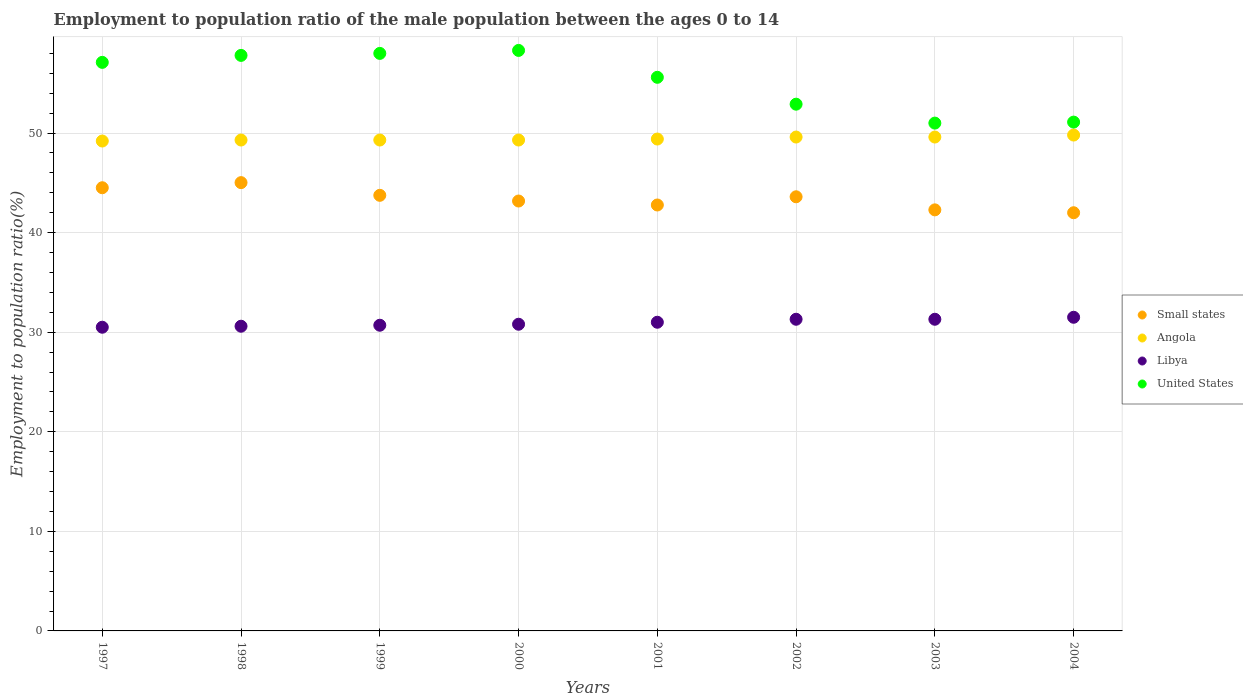How many different coloured dotlines are there?
Offer a terse response. 4. Is the number of dotlines equal to the number of legend labels?
Make the answer very short. Yes. What is the employment to population ratio in Small states in 2002?
Offer a very short reply. 43.6. Across all years, what is the maximum employment to population ratio in Libya?
Make the answer very short. 31.5. Across all years, what is the minimum employment to population ratio in Small states?
Provide a succinct answer. 42. In which year was the employment to population ratio in United States minimum?
Ensure brevity in your answer.  2003. What is the total employment to population ratio in Angola in the graph?
Keep it short and to the point. 395.5. What is the difference between the employment to population ratio in Libya in 1997 and that in 2003?
Offer a terse response. -0.8. What is the difference between the employment to population ratio in United States in 1997 and the employment to population ratio in Libya in 2000?
Make the answer very short. 26.3. What is the average employment to population ratio in Angola per year?
Offer a very short reply. 49.44. In the year 1998, what is the difference between the employment to population ratio in Angola and employment to population ratio in Small states?
Your answer should be compact. 4.28. What is the ratio of the employment to population ratio in Libya in 1997 to that in 2001?
Make the answer very short. 0.98. Is the difference between the employment to population ratio in Angola in 1999 and 2004 greater than the difference between the employment to population ratio in Small states in 1999 and 2004?
Ensure brevity in your answer.  No. What is the difference between the highest and the second highest employment to population ratio in United States?
Keep it short and to the point. 0.3. What is the difference between the highest and the lowest employment to population ratio in Libya?
Ensure brevity in your answer.  1. Is the sum of the employment to population ratio in Small states in 1997 and 2002 greater than the maximum employment to population ratio in Libya across all years?
Keep it short and to the point. Yes. Is it the case that in every year, the sum of the employment to population ratio in United States and employment to population ratio in Angola  is greater than the sum of employment to population ratio in Libya and employment to population ratio in Small states?
Make the answer very short. Yes. Is the employment to population ratio in Libya strictly less than the employment to population ratio in Small states over the years?
Your answer should be very brief. Yes. How many dotlines are there?
Provide a short and direct response. 4. Does the graph contain any zero values?
Provide a short and direct response. No. Where does the legend appear in the graph?
Provide a short and direct response. Center right. How many legend labels are there?
Your answer should be compact. 4. What is the title of the graph?
Your answer should be very brief. Employment to population ratio of the male population between the ages 0 to 14. What is the Employment to population ratio(%) in Small states in 1997?
Your response must be concise. 44.51. What is the Employment to population ratio(%) in Angola in 1997?
Your answer should be very brief. 49.2. What is the Employment to population ratio(%) in Libya in 1997?
Provide a succinct answer. 30.5. What is the Employment to population ratio(%) of United States in 1997?
Your answer should be compact. 57.1. What is the Employment to population ratio(%) of Small states in 1998?
Offer a terse response. 45.02. What is the Employment to population ratio(%) in Angola in 1998?
Keep it short and to the point. 49.3. What is the Employment to population ratio(%) of Libya in 1998?
Offer a very short reply. 30.6. What is the Employment to population ratio(%) of United States in 1998?
Offer a very short reply. 57.8. What is the Employment to population ratio(%) of Small states in 1999?
Provide a succinct answer. 43.75. What is the Employment to population ratio(%) of Angola in 1999?
Keep it short and to the point. 49.3. What is the Employment to population ratio(%) in Libya in 1999?
Provide a succinct answer. 30.7. What is the Employment to population ratio(%) of Small states in 2000?
Keep it short and to the point. 43.17. What is the Employment to population ratio(%) of Angola in 2000?
Provide a succinct answer. 49.3. What is the Employment to population ratio(%) of Libya in 2000?
Ensure brevity in your answer.  30.8. What is the Employment to population ratio(%) in United States in 2000?
Keep it short and to the point. 58.3. What is the Employment to population ratio(%) in Small states in 2001?
Offer a terse response. 42.78. What is the Employment to population ratio(%) of Angola in 2001?
Your answer should be very brief. 49.4. What is the Employment to population ratio(%) of United States in 2001?
Keep it short and to the point. 55.6. What is the Employment to population ratio(%) in Small states in 2002?
Your response must be concise. 43.6. What is the Employment to population ratio(%) of Angola in 2002?
Ensure brevity in your answer.  49.6. What is the Employment to population ratio(%) in Libya in 2002?
Your answer should be very brief. 31.3. What is the Employment to population ratio(%) of United States in 2002?
Your response must be concise. 52.9. What is the Employment to population ratio(%) of Small states in 2003?
Give a very brief answer. 42.29. What is the Employment to population ratio(%) of Angola in 2003?
Keep it short and to the point. 49.6. What is the Employment to population ratio(%) of Libya in 2003?
Offer a terse response. 31.3. What is the Employment to population ratio(%) of United States in 2003?
Keep it short and to the point. 51. What is the Employment to population ratio(%) of Small states in 2004?
Keep it short and to the point. 42. What is the Employment to population ratio(%) of Angola in 2004?
Your answer should be compact. 49.8. What is the Employment to population ratio(%) in Libya in 2004?
Give a very brief answer. 31.5. What is the Employment to population ratio(%) of United States in 2004?
Provide a succinct answer. 51.1. Across all years, what is the maximum Employment to population ratio(%) of Small states?
Ensure brevity in your answer.  45.02. Across all years, what is the maximum Employment to population ratio(%) in Angola?
Provide a short and direct response. 49.8. Across all years, what is the maximum Employment to population ratio(%) in Libya?
Your answer should be very brief. 31.5. Across all years, what is the maximum Employment to population ratio(%) in United States?
Provide a succinct answer. 58.3. Across all years, what is the minimum Employment to population ratio(%) of Small states?
Your response must be concise. 42. Across all years, what is the minimum Employment to population ratio(%) in Angola?
Provide a short and direct response. 49.2. Across all years, what is the minimum Employment to population ratio(%) in Libya?
Your answer should be very brief. 30.5. What is the total Employment to population ratio(%) in Small states in the graph?
Keep it short and to the point. 347.11. What is the total Employment to population ratio(%) in Angola in the graph?
Keep it short and to the point. 395.5. What is the total Employment to population ratio(%) of Libya in the graph?
Your answer should be very brief. 247.7. What is the total Employment to population ratio(%) in United States in the graph?
Provide a succinct answer. 441.8. What is the difference between the Employment to population ratio(%) in Small states in 1997 and that in 1998?
Offer a terse response. -0.51. What is the difference between the Employment to population ratio(%) in Angola in 1997 and that in 1998?
Your answer should be very brief. -0.1. What is the difference between the Employment to population ratio(%) of Libya in 1997 and that in 1998?
Ensure brevity in your answer.  -0.1. What is the difference between the Employment to population ratio(%) of United States in 1997 and that in 1998?
Provide a short and direct response. -0.7. What is the difference between the Employment to population ratio(%) of Small states in 1997 and that in 1999?
Provide a succinct answer. 0.76. What is the difference between the Employment to population ratio(%) of United States in 1997 and that in 1999?
Provide a succinct answer. -0.9. What is the difference between the Employment to population ratio(%) of Small states in 1997 and that in 2000?
Ensure brevity in your answer.  1.33. What is the difference between the Employment to population ratio(%) of Angola in 1997 and that in 2000?
Make the answer very short. -0.1. What is the difference between the Employment to population ratio(%) in Small states in 1997 and that in 2001?
Ensure brevity in your answer.  1.73. What is the difference between the Employment to population ratio(%) of Libya in 1997 and that in 2001?
Offer a very short reply. -0.5. What is the difference between the Employment to population ratio(%) of United States in 1997 and that in 2001?
Make the answer very short. 1.5. What is the difference between the Employment to population ratio(%) in Small states in 1997 and that in 2002?
Provide a succinct answer. 0.91. What is the difference between the Employment to population ratio(%) of United States in 1997 and that in 2002?
Your answer should be very brief. 4.2. What is the difference between the Employment to population ratio(%) of Small states in 1997 and that in 2003?
Ensure brevity in your answer.  2.22. What is the difference between the Employment to population ratio(%) of Angola in 1997 and that in 2003?
Make the answer very short. -0.4. What is the difference between the Employment to population ratio(%) of Libya in 1997 and that in 2003?
Ensure brevity in your answer.  -0.8. What is the difference between the Employment to population ratio(%) in United States in 1997 and that in 2003?
Your answer should be very brief. 6.1. What is the difference between the Employment to population ratio(%) in Small states in 1997 and that in 2004?
Provide a succinct answer. 2.51. What is the difference between the Employment to population ratio(%) of Libya in 1997 and that in 2004?
Provide a short and direct response. -1. What is the difference between the Employment to population ratio(%) of Small states in 1998 and that in 1999?
Keep it short and to the point. 1.27. What is the difference between the Employment to population ratio(%) of Angola in 1998 and that in 1999?
Make the answer very short. 0. What is the difference between the Employment to population ratio(%) in United States in 1998 and that in 1999?
Your answer should be compact. -0.2. What is the difference between the Employment to population ratio(%) in Small states in 1998 and that in 2000?
Ensure brevity in your answer.  1.85. What is the difference between the Employment to population ratio(%) in Angola in 1998 and that in 2000?
Give a very brief answer. 0. What is the difference between the Employment to population ratio(%) in United States in 1998 and that in 2000?
Give a very brief answer. -0.5. What is the difference between the Employment to population ratio(%) of Small states in 1998 and that in 2001?
Give a very brief answer. 2.25. What is the difference between the Employment to population ratio(%) in United States in 1998 and that in 2001?
Offer a terse response. 2.2. What is the difference between the Employment to population ratio(%) of Small states in 1998 and that in 2002?
Give a very brief answer. 1.42. What is the difference between the Employment to population ratio(%) of Angola in 1998 and that in 2002?
Your answer should be very brief. -0.3. What is the difference between the Employment to population ratio(%) in United States in 1998 and that in 2002?
Offer a very short reply. 4.9. What is the difference between the Employment to population ratio(%) in Small states in 1998 and that in 2003?
Offer a terse response. 2.73. What is the difference between the Employment to population ratio(%) of Libya in 1998 and that in 2003?
Your answer should be compact. -0.7. What is the difference between the Employment to population ratio(%) in United States in 1998 and that in 2003?
Your answer should be very brief. 6.8. What is the difference between the Employment to population ratio(%) of Small states in 1998 and that in 2004?
Your answer should be very brief. 3.02. What is the difference between the Employment to population ratio(%) of Libya in 1998 and that in 2004?
Your response must be concise. -0.9. What is the difference between the Employment to population ratio(%) of Small states in 1999 and that in 2000?
Your answer should be compact. 0.57. What is the difference between the Employment to population ratio(%) in Angola in 1999 and that in 2000?
Your answer should be very brief. 0. What is the difference between the Employment to population ratio(%) in United States in 1999 and that in 2000?
Ensure brevity in your answer.  -0.3. What is the difference between the Employment to population ratio(%) in Small states in 1999 and that in 2001?
Your response must be concise. 0.97. What is the difference between the Employment to population ratio(%) in Angola in 1999 and that in 2001?
Give a very brief answer. -0.1. What is the difference between the Employment to population ratio(%) of Small states in 1999 and that in 2002?
Provide a short and direct response. 0.15. What is the difference between the Employment to population ratio(%) of Angola in 1999 and that in 2002?
Offer a very short reply. -0.3. What is the difference between the Employment to population ratio(%) of Libya in 1999 and that in 2002?
Ensure brevity in your answer.  -0.6. What is the difference between the Employment to population ratio(%) in United States in 1999 and that in 2002?
Ensure brevity in your answer.  5.1. What is the difference between the Employment to population ratio(%) in Small states in 1999 and that in 2003?
Make the answer very short. 1.46. What is the difference between the Employment to population ratio(%) of Libya in 1999 and that in 2003?
Give a very brief answer. -0.6. What is the difference between the Employment to population ratio(%) of Small states in 1999 and that in 2004?
Make the answer very short. 1.75. What is the difference between the Employment to population ratio(%) in Angola in 1999 and that in 2004?
Provide a short and direct response. -0.5. What is the difference between the Employment to population ratio(%) of Libya in 1999 and that in 2004?
Offer a terse response. -0.8. What is the difference between the Employment to population ratio(%) in United States in 1999 and that in 2004?
Your response must be concise. 6.9. What is the difference between the Employment to population ratio(%) in Small states in 2000 and that in 2001?
Keep it short and to the point. 0.4. What is the difference between the Employment to population ratio(%) in Angola in 2000 and that in 2001?
Give a very brief answer. -0.1. What is the difference between the Employment to population ratio(%) in Libya in 2000 and that in 2001?
Your answer should be compact. -0.2. What is the difference between the Employment to population ratio(%) of Small states in 2000 and that in 2002?
Ensure brevity in your answer.  -0.43. What is the difference between the Employment to population ratio(%) in Angola in 2000 and that in 2002?
Offer a very short reply. -0.3. What is the difference between the Employment to population ratio(%) of Libya in 2000 and that in 2002?
Offer a terse response. -0.5. What is the difference between the Employment to population ratio(%) of Small states in 2000 and that in 2003?
Provide a short and direct response. 0.89. What is the difference between the Employment to population ratio(%) in Libya in 2000 and that in 2003?
Offer a very short reply. -0.5. What is the difference between the Employment to population ratio(%) in United States in 2000 and that in 2003?
Offer a terse response. 7.3. What is the difference between the Employment to population ratio(%) in Small states in 2000 and that in 2004?
Give a very brief answer. 1.18. What is the difference between the Employment to population ratio(%) of United States in 2000 and that in 2004?
Provide a succinct answer. 7.2. What is the difference between the Employment to population ratio(%) of Small states in 2001 and that in 2002?
Provide a succinct answer. -0.82. What is the difference between the Employment to population ratio(%) of Angola in 2001 and that in 2002?
Ensure brevity in your answer.  -0.2. What is the difference between the Employment to population ratio(%) of Libya in 2001 and that in 2002?
Provide a succinct answer. -0.3. What is the difference between the Employment to population ratio(%) in Small states in 2001 and that in 2003?
Your response must be concise. 0.49. What is the difference between the Employment to population ratio(%) of Angola in 2001 and that in 2003?
Make the answer very short. -0.2. What is the difference between the Employment to population ratio(%) of United States in 2001 and that in 2003?
Your answer should be very brief. 4.6. What is the difference between the Employment to population ratio(%) in Small states in 2001 and that in 2004?
Your response must be concise. 0.78. What is the difference between the Employment to population ratio(%) of Angola in 2001 and that in 2004?
Provide a short and direct response. -0.4. What is the difference between the Employment to population ratio(%) in Libya in 2001 and that in 2004?
Give a very brief answer. -0.5. What is the difference between the Employment to population ratio(%) of Small states in 2002 and that in 2003?
Make the answer very short. 1.31. What is the difference between the Employment to population ratio(%) in Libya in 2002 and that in 2003?
Your response must be concise. 0. What is the difference between the Employment to population ratio(%) of Small states in 2002 and that in 2004?
Your answer should be very brief. 1.6. What is the difference between the Employment to population ratio(%) of United States in 2002 and that in 2004?
Give a very brief answer. 1.8. What is the difference between the Employment to population ratio(%) of Small states in 2003 and that in 2004?
Offer a very short reply. 0.29. What is the difference between the Employment to population ratio(%) in United States in 2003 and that in 2004?
Provide a short and direct response. -0.1. What is the difference between the Employment to population ratio(%) in Small states in 1997 and the Employment to population ratio(%) in Angola in 1998?
Give a very brief answer. -4.79. What is the difference between the Employment to population ratio(%) in Small states in 1997 and the Employment to population ratio(%) in Libya in 1998?
Give a very brief answer. 13.91. What is the difference between the Employment to population ratio(%) of Small states in 1997 and the Employment to population ratio(%) of United States in 1998?
Give a very brief answer. -13.29. What is the difference between the Employment to population ratio(%) in Libya in 1997 and the Employment to population ratio(%) in United States in 1998?
Your answer should be very brief. -27.3. What is the difference between the Employment to population ratio(%) in Small states in 1997 and the Employment to population ratio(%) in Angola in 1999?
Offer a very short reply. -4.79. What is the difference between the Employment to population ratio(%) in Small states in 1997 and the Employment to population ratio(%) in Libya in 1999?
Provide a short and direct response. 13.81. What is the difference between the Employment to population ratio(%) in Small states in 1997 and the Employment to population ratio(%) in United States in 1999?
Make the answer very short. -13.49. What is the difference between the Employment to population ratio(%) of Angola in 1997 and the Employment to population ratio(%) of Libya in 1999?
Provide a succinct answer. 18.5. What is the difference between the Employment to population ratio(%) in Angola in 1997 and the Employment to population ratio(%) in United States in 1999?
Your answer should be very brief. -8.8. What is the difference between the Employment to population ratio(%) in Libya in 1997 and the Employment to population ratio(%) in United States in 1999?
Ensure brevity in your answer.  -27.5. What is the difference between the Employment to population ratio(%) in Small states in 1997 and the Employment to population ratio(%) in Angola in 2000?
Give a very brief answer. -4.79. What is the difference between the Employment to population ratio(%) of Small states in 1997 and the Employment to population ratio(%) of Libya in 2000?
Keep it short and to the point. 13.71. What is the difference between the Employment to population ratio(%) of Small states in 1997 and the Employment to population ratio(%) of United States in 2000?
Your answer should be very brief. -13.79. What is the difference between the Employment to population ratio(%) in Libya in 1997 and the Employment to population ratio(%) in United States in 2000?
Offer a terse response. -27.8. What is the difference between the Employment to population ratio(%) in Small states in 1997 and the Employment to population ratio(%) in Angola in 2001?
Your answer should be very brief. -4.89. What is the difference between the Employment to population ratio(%) of Small states in 1997 and the Employment to population ratio(%) of Libya in 2001?
Give a very brief answer. 13.51. What is the difference between the Employment to population ratio(%) of Small states in 1997 and the Employment to population ratio(%) of United States in 2001?
Provide a short and direct response. -11.09. What is the difference between the Employment to population ratio(%) in Angola in 1997 and the Employment to population ratio(%) in Libya in 2001?
Make the answer very short. 18.2. What is the difference between the Employment to population ratio(%) in Libya in 1997 and the Employment to population ratio(%) in United States in 2001?
Ensure brevity in your answer.  -25.1. What is the difference between the Employment to population ratio(%) in Small states in 1997 and the Employment to population ratio(%) in Angola in 2002?
Provide a short and direct response. -5.09. What is the difference between the Employment to population ratio(%) in Small states in 1997 and the Employment to population ratio(%) in Libya in 2002?
Ensure brevity in your answer.  13.21. What is the difference between the Employment to population ratio(%) of Small states in 1997 and the Employment to population ratio(%) of United States in 2002?
Ensure brevity in your answer.  -8.39. What is the difference between the Employment to population ratio(%) in Libya in 1997 and the Employment to population ratio(%) in United States in 2002?
Offer a terse response. -22.4. What is the difference between the Employment to population ratio(%) in Small states in 1997 and the Employment to population ratio(%) in Angola in 2003?
Make the answer very short. -5.09. What is the difference between the Employment to population ratio(%) in Small states in 1997 and the Employment to population ratio(%) in Libya in 2003?
Offer a very short reply. 13.21. What is the difference between the Employment to population ratio(%) in Small states in 1997 and the Employment to population ratio(%) in United States in 2003?
Keep it short and to the point. -6.49. What is the difference between the Employment to population ratio(%) in Libya in 1997 and the Employment to population ratio(%) in United States in 2003?
Provide a short and direct response. -20.5. What is the difference between the Employment to population ratio(%) of Small states in 1997 and the Employment to population ratio(%) of Angola in 2004?
Ensure brevity in your answer.  -5.29. What is the difference between the Employment to population ratio(%) of Small states in 1997 and the Employment to population ratio(%) of Libya in 2004?
Ensure brevity in your answer.  13.01. What is the difference between the Employment to population ratio(%) in Small states in 1997 and the Employment to population ratio(%) in United States in 2004?
Offer a terse response. -6.59. What is the difference between the Employment to population ratio(%) of Angola in 1997 and the Employment to population ratio(%) of United States in 2004?
Your response must be concise. -1.9. What is the difference between the Employment to population ratio(%) in Libya in 1997 and the Employment to population ratio(%) in United States in 2004?
Give a very brief answer. -20.6. What is the difference between the Employment to population ratio(%) in Small states in 1998 and the Employment to population ratio(%) in Angola in 1999?
Provide a succinct answer. -4.28. What is the difference between the Employment to population ratio(%) in Small states in 1998 and the Employment to population ratio(%) in Libya in 1999?
Your response must be concise. 14.32. What is the difference between the Employment to population ratio(%) of Small states in 1998 and the Employment to population ratio(%) of United States in 1999?
Give a very brief answer. -12.98. What is the difference between the Employment to population ratio(%) of Libya in 1998 and the Employment to population ratio(%) of United States in 1999?
Offer a terse response. -27.4. What is the difference between the Employment to population ratio(%) in Small states in 1998 and the Employment to population ratio(%) in Angola in 2000?
Make the answer very short. -4.28. What is the difference between the Employment to population ratio(%) in Small states in 1998 and the Employment to population ratio(%) in Libya in 2000?
Keep it short and to the point. 14.22. What is the difference between the Employment to population ratio(%) of Small states in 1998 and the Employment to population ratio(%) of United States in 2000?
Make the answer very short. -13.28. What is the difference between the Employment to population ratio(%) in Angola in 1998 and the Employment to population ratio(%) in United States in 2000?
Your response must be concise. -9. What is the difference between the Employment to population ratio(%) of Libya in 1998 and the Employment to population ratio(%) of United States in 2000?
Ensure brevity in your answer.  -27.7. What is the difference between the Employment to population ratio(%) in Small states in 1998 and the Employment to population ratio(%) in Angola in 2001?
Provide a succinct answer. -4.38. What is the difference between the Employment to population ratio(%) of Small states in 1998 and the Employment to population ratio(%) of Libya in 2001?
Keep it short and to the point. 14.02. What is the difference between the Employment to population ratio(%) of Small states in 1998 and the Employment to population ratio(%) of United States in 2001?
Your response must be concise. -10.58. What is the difference between the Employment to population ratio(%) in Angola in 1998 and the Employment to population ratio(%) in United States in 2001?
Give a very brief answer. -6.3. What is the difference between the Employment to population ratio(%) of Libya in 1998 and the Employment to population ratio(%) of United States in 2001?
Make the answer very short. -25. What is the difference between the Employment to population ratio(%) of Small states in 1998 and the Employment to population ratio(%) of Angola in 2002?
Give a very brief answer. -4.58. What is the difference between the Employment to population ratio(%) in Small states in 1998 and the Employment to population ratio(%) in Libya in 2002?
Offer a very short reply. 13.72. What is the difference between the Employment to population ratio(%) of Small states in 1998 and the Employment to population ratio(%) of United States in 2002?
Keep it short and to the point. -7.88. What is the difference between the Employment to population ratio(%) in Angola in 1998 and the Employment to population ratio(%) in Libya in 2002?
Offer a terse response. 18. What is the difference between the Employment to population ratio(%) of Angola in 1998 and the Employment to population ratio(%) of United States in 2002?
Give a very brief answer. -3.6. What is the difference between the Employment to population ratio(%) in Libya in 1998 and the Employment to population ratio(%) in United States in 2002?
Keep it short and to the point. -22.3. What is the difference between the Employment to population ratio(%) of Small states in 1998 and the Employment to population ratio(%) of Angola in 2003?
Give a very brief answer. -4.58. What is the difference between the Employment to population ratio(%) in Small states in 1998 and the Employment to population ratio(%) in Libya in 2003?
Ensure brevity in your answer.  13.72. What is the difference between the Employment to population ratio(%) of Small states in 1998 and the Employment to population ratio(%) of United States in 2003?
Offer a terse response. -5.98. What is the difference between the Employment to population ratio(%) in Angola in 1998 and the Employment to population ratio(%) in Libya in 2003?
Your answer should be compact. 18. What is the difference between the Employment to population ratio(%) of Angola in 1998 and the Employment to population ratio(%) of United States in 2003?
Provide a succinct answer. -1.7. What is the difference between the Employment to population ratio(%) of Libya in 1998 and the Employment to population ratio(%) of United States in 2003?
Offer a very short reply. -20.4. What is the difference between the Employment to population ratio(%) of Small states in 1998 and the Employment to population ratio(%) of Angola in 2004?
Offer a terse response. -4.78. What is the difference between the Employment to population ratio(%) of Small states in 1998 and the Employment to population ratio(%) of Libya in 2004?
Make the answer very short. 13.52. What is the difference between the Employment to population ratio(%) in Small states in 1998 and the Employment to population ratio(%) in United States in 2004?
Ensure brevity in your answer.  -6.08. What is the difference between the Employment to population ratio(%) of Angola in 1998 and the Employment to population ratio(%) of United States in 2004?
Provide a succinct answer. -1.8. What is the difference between the Employment to population ratio(%) in Libya in 1998 and the Employment to population ratio(%) in United States in 2004?
Ensure brevity in your answer.  -20.5. What is the difference between the Employment to population ratio(%) in Small states in 1999 and the Employment to population ratio(%) in Angola in 2000?
Your response must be concise. -5.55. What is the difference between the Employment to population ratio(%) in Small states in 1999 and the Employment to population ratio(%) in Libya in 2000?
Give a very brief answer. 12.95. What is the difference between the Employment to population ratio(%) of Small states in 1999 and the Employment to population ratio(%) of United States in 2000?
Give a very brief answer. -14.55. What is the difference between the Employment to population ratio(%) in Angola in 1999 and the Employment to population ratio(%) in United States in 2000?
Your answer should be very brief. -9. What is the difference between the Employment to population ratio(%) of Libya in 1999 and the Employment to population ratio(%) of United States in 2000?
Your answer should be compact. -27.6. What is the difference between the Employment to population ratio(%) in Small states in 1999 and the Employment to population ratio(%) in Angola in 2001?
Offer a terse response. -5.65. What is the difference between the Employment to population ratio(%) in Small states in 1999 and the Employment to population ratio(%) in Libya in 2001?
Provide a succinct answer. 12.75. What is the difference between the Employment to population ratio(%) in Small states in 1999 and the Employment to population ratio(%) in United States in 2001?
Your answer should be very brief. -11.85. What is the difference between the Employment to population ratio(%) of Angola in 1999 and the Employment to population ratio(%) of United States in 2001?
Your answer should be very brief. -6.3. What is the difference between the Employment to population ratio(%) in Libya in 1999 and the Employment to population ratio(%) in United States in 2001?
Your answer should be compact. -24.9. What is the difference between the Employment to population ratio(%) of Small states in 1999 and the Employment to population ratio(%) of Angola in 2002?
Give a very brief answer. -5.85. What is the difference between the Employment to population ratio(%) of Small states in 1999 and the Employment to population ratio(%) of Libya in 2002?
Make the answer very short. 12.45. What is the difference between the Employment to population ratio(%) of Small states in 1999 and the Employment to population ratio(%) of United States in 2002?
Your response must be concise. -9.15. What is the difference between the Employment to population ratio(%) of Angola in 1999 and the Employment to population ratio(%) of United States in 2002?
Ensure brevity in your answer.  -3.6. What is the difference between the Employment to population ratio(%) in Libya in 1999 and the Employment to population ratio(%) in United States in 2002?
Offer a very short reply. -22.2. What is the difference between the Employment to population ratio(%) in Small states in 1999 and the Employment to population ratio(%) in Angola in 2003?
Your response must be concise. -5.85. What is the difference between the Employment to population ratio(%) of Small states in 1999 and the Employment to population ratio(%) of Libya in 2003?
Provide a succinct answer. 12.45. What is the difference between the Employment to population ratio(%) in Small states in 1999 and the Employment to population ratio(%) in United States in 2003?
Your answer should be very brief. -7.25. What is the difference between the Employment to population ratio(%) of Angola in 1999 and the Employment to population ratio(%) of United States in 2003?
Offer a terse response. -1.7. What is the difference between the Employment to population ratio(%) in Libya in 1999 and the Employment to population ratio(%) in United States in 2003?
Provide a succinct answer. -20.3. What is the difference between the Employment to population ratio(%) in Small states in 1999 and the Employment to population ratio(%) in Angola in 2004?
Keep it short and to the point. -6.05. What is the difference between the Employment to population ratio(%) in Small states in 1999 and the Employment to population ratio(%) in Libya in 2004?
Your answer should be very brief. 12.25. What is the difference between the Employment to population ratio(%) in Small states in 1999 and the Employment to population ratio(%) in United States in 2004?
Your response must be concise. -7.35. What is the difference between the Employment to population ratio(%) in Angola in 1999 and the Employment to population ratio(%) in Libya in 2004?
Keep it short and to the point. 17.8. What is the difference between the Employment to population ratio(%) of Libya in 1999 and the Employment to population ratio(%) of United States in 2004?
Ensure brevity in your answer.  -20.4. What is the difference between the Employment to population ratio(%) in Small states in 2000 and the Employment to population ratio(%) in Angola in 2001?
Your response must be concise. -6.23. What is the difference between the Employment to population ratio(%) in Small states in 2000 and the Employment to population ratio(%) in Libya in 2001?
Your answer should be very brief. 12.17. What is the difference between the Employment to population ratio(%) in Small states in 2000 and the Employment to population ratio(%) in United States in 2001?
Provide a short and direct response. -12.43. What is the difference between the Employment to population ratio(%) of Angola in 2000 and the Employment to population ratio(%) of United States in 2001?
Your response must be concise. -6.3. What is the difference between the Employment to population ratio(%) in Libya in 2000 and the Employment to population ratio(%) in United States in 2001?
Provide a succinct answer. -24.8. What is the difference between the Employment to population ratio(%) in Small states in 2000 and the Employment to population ratio(%) in Angola in 2002?
Your answer should be compact. -6.43. What is the difference between the Employment to population ratio(%) of Small states in 2000 and the Employment to population ratio(%) of Libya in 2002?
Your response must be concise. 11.87. What is the difference between the Employment to population ratio(%) in Small states in 2000 and the Employment to population ratio(%) in United States in 2002?
Your answer should be compact. -9.73. What is the difference between the Employment to population ratio(%) in Angola in 2000 and the Employment to population ratio(%) in Libya in 2002?
Offer a very short reply. 18. What is the difference between the Employment to population ratio(%) of Angola in 2000 and the Employment to population ratio(%) of United States in 2002?
Offer a very short reply. -3.6. What is the difference between the Employment to population ratio(%) of Libya in 2000 and the Employment to population ratio(%) of United States in 2002?
Your answer should be very brief. -22.1. What is the difference between the Employment to population ratio(%) of Small states in 2000 and the Employment to population ratio(%) of Angola in 2003?
Provide a short and direct response. -6.43. What is the difference between the Employment to population ratio(%) in Small states in 2000 and the Employment to population ratio(%) in Libya in 2003?
Provide a short and direct response. 11.87. What is the difference between the Employment to population ratio(%) of Small states in 2000 and the Employment to population ratio(%) of United States in 2003?
Your response must be concise. -7.83. What is the difference between the Employment to population ratio(%) in Angola in 2000 and the Employment to population ratio(%) in United States in 2003?
Provide a succinct answer. -1.7. What is the difference between the Employment to population ratio(%) in Libya in 2000 and the Employment to population ratio(%) in United States in 2003?
Offer a terse response. -20.2. What is the difference between the Employment to population ratio(%) in Small states in 2000 and the Employment to population ratio(%) in Angola in 2004?
Your response must be concise. -6.63. What is the difference between the Employment to population ratio(%) in Small states in 2000 and the Employment to population ratio(%) in Libya in 2004?
Provide a short and direct response. 11.67. What is the difference between the Employment to population ratio(%) in Small states in 2000 and the Employment to population ratio(%) in United States in 2004?
Ensure brevity in your answer.  -7.93. What is the difference between the Employment to population ratio(%) of Libya in 2000 and the Employment to population ratio(%) of United States in 2004?
Give a very brief answer. -20.3. What is the difference between the Employment to population ratio(%) of Small states in 2001 and the Employment to population ratio(%) of Angola in 2002?
Provide a succinct answer. -6.82. What is the difference between the Employment to population ratio(%) of Small states in 2001 and the Employment to population ratio(%) of Libya in 2002?
Your answer should be compact. 11.48. What is the difference between the Employment to population ratio(%) in Small states in 2001 and the Employment to population ratio(%) in United States in 2002?
Your answer should be very brief. -10.12. What is the difference between the Employment to population ratio(%) of Angola in 2001 and the Employment to population ratio(%) of Libya in 2002?
Your response must be concise. 18.1. What is the difference between the Employment to population ratio(%) in Angola in 2001 and the Employment to population ratio(%) in United States in 2002?
Offer a very short reply. -3.5. What is the difference between the Employment to population ratio(%) in Libya in 2001 and the Employment to population ratio(%) in United States in 2002?
Ensure brevity in your answer.  -21.9. What is the difference between the Employment to population ratio(%) in Small states in 2001 and the Employment to population ratio(%) in Angola in 2003?
Offer a terse response. -6.82. What is the difference between the Employment to population ratio(%) of Small states in 2001 and the Employment to population ratio(%) of Libya in 2003?
Your response must be concise. 11.48. What is the difference between the Employment to population ratio(%) in Small states in 2001 and the Employment to population ratio(%) in United States in 2003?
Offer a very short reply. -8.22. What is the difference between the Employment to population ratio(%) of Small states in 2001 and the Employment to population ratio(%) of Angola in 2004?
Make the answer very short. -7.02. What is the difference between the Employment to population ratio(%) of Small states in 2001 and the Employment to population ratio(%) of Libya in 2004?
Provide a short and direct response. 11.28. What is the difference between the Employment to population ratio(%) of Small states in 2001 and the Employment to population ratio(%) of United States in 2004?
Offer a very short reply. -8.32. What is the difference between the Employment to population ratio(%) of Angola in 2001 and the Employment to population ratio(%) of Libya in 2004?
Give a very brief answer. 17.9. What is the difference between the Employment to population ratio(%) in Libya in 2001 and the Employment to population ratio(%) in United States in 2004?
Give a very brief answer. -20.1. What is the difference between the Employment to population ratio(%) of Small states in 2002 and the Employment to population ratio(%) of Angola in 2003?
Provide a short and direct response. -6. What is the difference between the Employment to population ratio(%) of Small states in 2002 and the Employment to population ratio(%) of Libya in 2003?
Ensure brevity in your answer.  12.3. What is the difference between the Employment to population ratio(%) of Small states in 2002 and the Employment to population ratio(%) of United States in 2003?
Your answer should be compact. -7.4. What is the difference between the Employment to population ratio(%) of Angola in 2002 and the Employment to population ratio(%) of Libya in 2003?
Your answer should be compact. 18.3. What is the difference between the Employment to population ratio(%) in Libya in 2002 and the Employment to population ratio(%) in United States in 2003?
Offer a terse response. -19.7. What is the difference between the Employment to population ratio(%) of Small states in 2002 and the Employment to population ratio(%) of Angola in 2004?
Your answer should be very brief. -6.2. What is the difference between the Employment to population ratio(%) in Small states in 2002 and the Employment to population ratio(%) in Libya in 2004?
Offer a terse response. 12.1. What is the difference between the Employment to population ratio(%) in Small states in 2002 and the Employment to population ratio(%) in United States in 2004?
Give a very brief answer. -7.5. What is the difference between the Employment to population ratio(%) in Angola in 2002 and the Employment to population ratio(%) in Libya in 2004?
Keep it short and to the point. 18.1. What is the difference between the Employment to population ratio(%) of Angola in 2002 and the Employment to population ratio(%) of United States in 2004?
Your answer should be very brief. -1.5. What is the difference between the Employment to population ratio(%) in Libya in 2002 and the Employment to population ratio(%) in United States in 2004?
Offer a very short reply. -19.8. What is the difference between the Employment to population ratio(%) of Small states in 2003 and the Employment to population ratio(%) of Angola in 2004?
Give a very brief answer. -7.51. What is the difference between the Employment to population ratio(%) in Small states in 2003 and the Employment to population ratio(%) in Libya in 2004?
Offer a terse response. 10.79. What is the difference between the Employment to population ratio(%) of Small states in 2003 and the Employment to population ratio(%) of United States in 2004?
Provide a succinct answer. -8.81. What is the difference between the Employment to population ratio(%) in Angola in 2003 and the Employment to population ratio(%) in Libya in 2004?
Provide a succinct answer. 18.1. What is the difference between the Employment to population ratio(%) of Angola in 2003 and the Employment to population ratio(%) of United States in 2004?
Keep it short and to the point. -1.5. What is the difference between the Employment to population ratio(%) of Libya in 2003 and the Employment to population ratio(%) of United States in 2004?
Your answer should be compact. -19.8. What is the average Employment to population ratio(%) in Small states per year?
Your response must be concise. 43.39. What is the average Employment to population ratio(%) of Angola per year?
Your answer should be very brief. 49.44. What is the average Employment to population ratio(%) of Libya per year?
Your answer should be very brief. 30.96. What is the average Employment to population ratio(%) of United States per year?
Provide a succinct answer. 55.23. In the year 1997, what is the difference between the Employment to population ratio(%) of Small states and Employment to population ratio(%) of Angola?
Keep it short and to the point. -4.69. In the year 1997, what is the difference between the Employment to population ratio(%) in Small states and Employment to population ratio(%) in Libya?
Make the answer very short. 14.01. In the year 1997, what is the difference between the Employment to population ratio(%) in Small states and Employment to population ratio(%) in United States?
Offer a terse response. -12.59. In the year 1997, what is the difference between the Employment to population ratio(%) of Angola and Employment to population ratio(%) of United States?
Make the answer very short. -7.9. In the year 1997, what is the difference between the Employment to population ratio(%) in Libya and Employment to population ratio(%) in United States?
Give a very brief answer. -26.6. In the year 1998, what is the difference between the Employment to population ratio(%) of Small states and Employment to population ratio(%) of Angola?
Make the answer very short. -4.28. In the year 1998, what is the difference between the Employment to population ratio(%) of Small states and Employment to population ratio(%) of Libya?
Ensure brevity in your answer.  14.42. In the year 1998, what is the difference between the Employment to population ratio(%) of Small states and Employment to population ratio(%) of United States?
Offer a terse response. -12.78. In the year 1998, what is the difference between the Employment to population ratio(%) of Libya and Employment to population ratio(%) of United States?
Provide a succinct answer. -27.2. In the year 1999, what is the difference between the Employment to population ratio(%) of Small states and Employment to population ratio(%) of Angola?
Ensure brevity in your answer.  -5.55. In the year 1999, what is the difference between the Employment to population ratio(%) in Small states and Employment to population ratio(%) in Libya?
Provide a short and direct response. 13.05. In the year 1999, what is the difference between the Employment to population ratio(%) of Small states and Employment to population ratio(%) of United States?
Make the answer very short. -14.25. In the year 1999, what is the difference between the Employment to population ratio(%) in Angola and Employment to population ratio(%) in Libya?
Provide a succinct answer. 18.6. In the year 1999, what is the difference between the Employment to population ratio(%) of Angola and Employment to population ratio(%) of United States?
Offer a terse response. -8.7. In the year 1999, what is the difference between the Employment to population ratio(%) of Libya and Employment to population ratio(%) of United States?
Your answer should be very brief. -27.3. In the year 2000, what is the difference between the Employment to population ratio(%) in Small states and Employment to population ratio(%) in Angola?
Your answer should be very brief. -6.13. In the year 2000, what is the difference between the Employment to population ratio(%) in Small states and Employment to population ratio(%) in Libya?
Your response must be concise. 12.37. In the year 2000, what is the difference between the Employment to population ratio(%) in Small states and Employment to population ratio(%) in United States?
Your answer should be very brief. -15.13. In the year 2000, what is the difference between the Employment to population ratio(%) in Angola and Employment to population ratio(%) in Libya?
Keep it short and to the point. 18.5. In the year 2000, what is the difference between the Employment to population ratio(%) of Libya and Employment to population ratio(%) of United States?
Ensure brevity in your answer.  -27.5. In the year 2001, what is the difference between the Employment to population ratio(%) in Small states and Employment to population ratio(%) in Angola?
Your answer should be compact. -6.62. In the year 2001, what is the difference between the Employment to population ratio(%) of Small states and Employment to population ratio(%) of Libya?
Keep it short and to the point. 11.78. In the year 2001, what is the difference between the Employment to population ratio(%) of Small states and Employment to population ratio(%) of United States?
Ensure brevity in your answer.  -12.82. In the year 2001, what is the difference between the Employment to population ratio(%) in Angola and Employment to population ratio(%) in Libya?
Provide a succinct answer. 18.4. In the year 2001, what is the difference between the Employment to population ratio(%) of Angola and Employment to population ratio(%) of United States?
Keep it short and to the point. -6.2. In the year 2001, what is the difference between the Employment to population ratio(%) of Libya and Employment to population ratio(%) of United States?
Ensure brevity in your answer.  -24.6. In the year 2002, what is the difference between the Employment to population ratio(%) in Small states and Employment to population ratio(%) in Angola?
Your response must be concise. -6. In the year 2002, what is the difference between the Employment to population ratio(%) of Small states and Employment to population ratio(%) of Libya?
Provide a succinct answer. 12.3. In the year 2002, what is the difference between the Employment to population ratio(%) of Small states and Employment to population ratio(%) of United States?
Your response must be concise. -9.3. In the year 2002, what is the difference between the Employment to population ratio(%) of Angola and Employment to population ratio(%) of Libya?
Your answer should be very brief. 18.3. In the year 2002, what is the difference between the Employment to population ratio(%) of Libya and Employment to population ratio(%) of United States?
Offer a very short reply. -21.6. In the year 2003, what is the difference between the Employment to population ratio(%) of Small states and Employment to population ratio(%) of Angola?
Ensure brevity in your answer.  -7.31. In the year 2003, what is the difference between the Employment to population ratio(%) in Small states and Employment to population ratio(%) in Libya?
Give a very brief answer. 10.99. In the year 2003, what is the difference between the Employment to population ratio(%) in Small states and Employment to population ratio(%) in United States?
Your response must be concise. -8.71. In the year 2003, what is the difference between the Employment to population ratio(%) of Angola and Employment to population ratio(%) of Libya?
Make the answer very short. 18.3. In the year 2003, what is the difference between the Employment to population ratio(%) in Angola and Employment to population ratio(%) in United States?
Your answer should be very brief. -1.4. In the year 2003, what is the difference between the Employment to population ratio(%) in Libya and Employment to population ratio(%) in United States?
Provide a short and direct response. -19.7. In the year 2004, what is the difference between the Employment to population ratio(%) of Small states and Employment to population ratio(%) of Angola?
Your answer should be very brief. -7.8. In the year 2004, what is the difference between the Employment to population ratio(%) in Small states and Employment to population ratio(%) in Libya?
Your response must be concise. 10.5. In the year 2004, what is the difference between the Employment to population ratio(%) in Small states and Employment to population ratio(%) in United States?
Your answer should be compact. -9.1. In the year 2004, what is the difference between the Employment to population ratio(%) of Angola and Employment to population ratio(%) of Libya?
Keep it short and to the point. 18.3. In the year 2004, what is the difference between the Employment to population ratio(%) in Angola and Employment to population ratio(%) in United States?
Make the answer very short. -1.3. In the year 2004, what is the difference between the Employment to population ratio(%) in Libya and Employment to population ratio(%) in United States?
Give a very brief answer. -19.6. What is the ratio of the Employment to population ratio(%) of Small states in 1997 to that in 1998?
Your response must be concise. 0.99. What is the ratio of the Employment to population ratio(%) of Libya in 1997 to that in 1998?
Make the answer very short. 1. What is the ratio of the Employment to population ratio(%) of United States in 1997 to that in 1998?
Offer a very short reply. 0.99. What is the ratio of the Employment to population ratio(%) in Small states in 1997 to that in 1999?
Your response must be concise. 1.02. What is the ratio of the Employment to population ratio(%) in Angola in 1997 to that in 1999?
Your response must be concise. 1. What is the ratio of the Employment to population ratio(%) of United States in 1997 to that in 1999?
Keep it short and to the point. 0.98. What is the ratio of the Employment to population ratio(%) in Small states in 1997 to that in 2000?
Offer a very short reply. 1.03. What is the ratio of the Employment to population ratio(%) of Libya in 1997 to that in 2000?
Your answer should be compact. 0.99. What is the ratio of the Employment to population ratio(%) of United States in 1997 to that in 2000?
Keep it short and to the point. 0.98. What is the ratio of the Employment to population ratio(%) in Small states in 1997 to that in 2001?
Provide a short and direct response. 1.04. What is the ratio of the Employment to population ratio(%) of Angola in 1997 to that in 2001?
Give a very brief answer. 1. What is the ratio of the Employment to population ratio(%) in Libya in 1997 to that in 2001?
Provide a short and direct response. 0.98. What is the ratio of the Employment to population ratio(%) of Small states in 1997 to that in 2002?
Your answer should be very brief. 1.02. What is the ratio of the Employment to population ratio(%) of Angola in 1997 to that in 2002?
Ensure brevity in your answer.  0.99. What is the ratio of the Employment to population ratio(%) in Libya in 1997 to that in 2002?
Ensure brevity in your answer.  0.97. What is the ratio of the Employment to population ratio(%) of United States in 1997 to that in 2002?
Your response must be concise. 1.08. What is the ratio of the Employment to population ratio(%) of Small states in 1997 to that in 2003?
Give a very brief answer. 1.05. What is the ratio of the Employment to population ratio(%) in Libya in 1997 to that in 2003?
Your response must be concise. 0.97. What is the ratio of the Employment to population ratio(%) in United States in 1997 to that in 2003?
Make the answer very short. 1.12. What is the ratio of the Employment to population ratio(%) in Small states in 1997 to that in 2004?
Offer a terse response. 1.06. What is the ratio of the Employment to population ratio(%) of Libya in 1997 to that in 2004?
Provide a succinct answer. 0.97. What is the ratio of the Employment to population ratio(%) of United States in 1997 to that in 2004?
Make the answer very short. 1.12. What is the ratio of the Employment to population ratio(%) of Small states in 1998 to that in 1999?
Your answer should be compact. 1.03. What is the ratio of the Employment to population ratio(%) of Libya in 1998 to that in 1999?
Ensure brevity in your answer.  1. What is the ratio of the Employment to population ratio(%) of United States in 1998 to that in 1999?
Keep it short and to the point. 1. What is the ratio of the Employment to population ratio(%) in Small states in 1998 to that in 2000?
Provide a succinct answer. 1.04. What is the ratio of the Employment to population ratio(%) of Libya in 1998 to that in 2000?
Ensure brevity in your answer.  0.99. What is the ratio of the Employment to population ratio(%) of United States in 1998 to that in 2000?
Offer a terse response. 0.99. What is the ratio of the Employment to population ratio(%) of Small states in 1998 to that in 2001?
Ensure brevity in your answer.  1.05. What is the ratio of the Employment to population ratio(%) of Angola in 1998 to that in 2001?
Keep it short and to the point. 1. What is the ratio of the Employment to population ratio(%) in Libya in 1998 to that in 2001?
Your answer should be compact. 0.99. What is the ratio of the Employment to population ratio(%) in United States in 1998 to that in 2001?
Make the answer very short. 1.04. What is the ratio of the Employment to population ratio(%) in Small states in 1998 to that in 2002?
Your answer should be very brief. 1.03. What is the ratio of the Employment to population ratio(%) in Angola in 1998 to that in 2002?
Provide a succinct answer. 0.99. What is the ratio of the Employment to population ratio(%) in Libya in 1998 to that in 2002?
Your answer should be very brief. 0.98. What is the ratio of the Employment to population ratio(%) of United States in 1998 to that in 2002?
Your answer should be very brief. 1.09. What is the ratio of the Employment to population ratio(%) in Small states in 1998 to that in 2003?
Offer a very short reply. 1.06. What is the ratio of the Employment to population ratio(%) in Angola in 1998 to that in 2003?
Provide a short and direct response. 0.99. What is the ratio of the Employment to population ratio(%) in Libya in 1998 to that in 2003?
Your answer should be very brief. 0.98. What is the ratio of the Employment to population ratio(%) in United States in 1998 to that in 2003?
Your response must be concise. 1.13. What is the ratio of the Employment to population ratio(%) in Small states in 1998 to that in 2004?
Ensure brevity in your answer.  1.07. What is the ratio of the Employment to population ratio(%) in Libya in 1998 to that in 2004?
Keep it short and to the point. 0.97. What is the ratio of the Employment to population ratio(%) in United States in 1998 to that in 2004?
Offer a very short reply. 1.13. What is the ratio of the Employment to population ratio(%) in Small states in 1999 to that in 2000?
Offer a terse response. 1.01. What is the ratio of the Employment to population ratio(%) in Libya in 1999 to that in 2000?
Ensure brevity in your answer.  1. What is the ratio of the Employment to population ratio(%) in Small states in 1999 to that in 2001?
Provide a succinct answer. 1.02. What is the ratio of the Employment to population ratio(%) in Angola in 1999 to that in 2001?
Make the answer very short. 1. What is the ratio of the Employment to population ratio(%) of Libya in 1999 to that in 2001?
Provide a short and direct response. 0.99. What is the ratio of the Employment to population ratio(%) of United States in 1999 to that in 2001?
Your answer should be very brief. 1.04. What is the ratio of the Employment to population ratio(%) in Libya in 1999 to that in 2002?
Provide a succinct answer. 0.98. What is the ratio of the Employment to population ratio(%) of United States in 1999 to that in 2002?
Your answer should be compact. 1.1. What is the ratio of the Employment to population ratio(%) in Small states in 1999 to that in 2003?
Your answer should be compact. 1.03. What is the ratio of the Employment to population ratio(%) in Angola in 1999 to that in 2003?
Provide a succinct answer. 0.99. What is the ratio of the Employment to population ratio(%) of Libya in 1999 to that in 2003?
Give a very brief answer. 0.98. What is the ratio of the Employment to population ratio(%) of United States in 1999 to that in 2003?
Provide a short and direct response. 1.14. What is the ratio of the Employment to population ratio(%) in Small states in 1999 to that in 2004?
Your answer should be compact. 1.04. What is the ratio of the Employment to population ratio(%) in Angola in 1999 to that in 2004?
Keep it short and to the point. 0.99. What is the ratio of the Employment to population ratio(%) of Libya in 1999 to that in 2004?
Keep it short and to the point. 0.97. What is the ratio of the Employment to population ratio(%) of United States in 1999 to that in 2004?
Your answer should be very brief. 1.14. What is the ratio of the Employment to population ratio(%) in Small states in 2000 to that in 2001?
Ensure brevity in your answer.  1.01. What is the ratio of the Employment to population ratio(%) of Angola in 2000 to that in 2001?
Provide a succinct answer. 1. What is the ratio of the Employment to population ratio(%) in Libya in 2000 to that in 2001?
Your answer should be compact. 0.99. What is the ratio of the Employment to population ratio(%) of United States in 2000 to that in 2001?
Give a very brief answer. 1.05. What is the ratio of the Employment to population ratio(%) of Small states in 2000 to that in 2002?
Give a very brief answer. 0.99. What is the ratio of the Employment to population ratio(%) of Angola in 2000 to that in 2002?
Keep it short and to the point. 0.99. What is the ratio of the Employment to population ratio(%) of Libya in 2000 to that in 2002?
Your answer should be very brief. 0.98. What is the ratio of the Employment to population ratio(%) of United States in 2000 to that in 2002?
Ensure brevity in your answer.  1.1. What is the ratio of the Employment to population ratio(%) in Angola in 2000 to that in 2003?
Your answer should be very brief. 0.99. What is the ratio of the Employment to population ratio(%) in Libya in 2000 to that in 2003?
Offer a very short reply. 0.98. What is the ratio of the Employment to population ratio(%) in United States in 2000 to that in 2003?
Make the answer very short. 1.14. What is the ratio of the Employment to population ratio(%) in Small states in 2000 to that in 2004?
Make the answer very short. 1.03. What is the ratio of the Employment to population ratio(%) of Libya in 2000 to that in 2004?
Ensure brevity in your answer.  0.98. What is the ratio of the Employment to population ratio(%) of United States in 2000 to that in 2004?
Ensure brevity in your answer.  1.14. What is the ratio of the Employment to population ratio(%) in Small states in 2001 to that in 2002?
Provide a succinct answer. 0.98. What is the ratio of the Employment to population ratio(%) in Angola in 2001 to that in 2002?
Give a very brief answer. 1. What is the ratio of the Employment to population ratio(%) in Libya in 2001 to that in 2002?
Make the answer very short. 0.99. What is the ratio of the Employment to population ratio(%) of United States in 2001 to that in 2002?
Keep it short and to the point. 1.05. What is the ratio of the Employment to population ratio(%) in Small states in 2001 to that in 2003?
Provide a short and direct response. 1.01. What is the ratio of the Employment to population ratio(%) in Angola in 2001 to that in 2003?
Ensure brevity in your answer.  1. What is the ratio of the Employment to population ratio(%) in United States in 2001 to that in 2003?
Offer a terse response. 1.09. What is the ratio of the Employment to population ratio(%) in Small states in 2001 to that in 2004?
Make the answer very short. 1.02. What is the ratio of the Employment to population ratio(%) of Libya in 2001 to that in 2004?
Offer a very short reply. 0.98. What is the ratio of the Employment to population ratio(%) in United States in 2001 to that in 2004?
Provide a short and direct response. 1.09. What is the ratio of the Employment to population ratio(%) in Small states in 2002 to that in 2003?
Ensure brevity in your answer.  1.03. What is the ratio of the Employment to population ratio(%) of Angola in 2002 to that in 2003?
Your answer should be very brief. 1. What is the ratio of the Employment to population ratio(%) in United States in 2002 to that in 2003?
Ensure brevity in your answer.  1.04. What is the ratio of the Employment to population ratio(%) of Small states in 2002 to that in 2004?
Your answer should be compact. 1.04. What is the ratio of the Employment to population ratio(%) in United States in 2002 to that in 2004?
Make the answer very short. 1.04. What is the ratio of the Employment to population ratio(%) of Small states in 2003 to that in 2004?
Offer a terse response. 1.01. What is the difference between the highest and the second highest Employment to population ratio(%) in Small states?
Offer a very short reply. 0.51. What is the difference between the highest and the second highest Employment to population ratio(%) of Libya?
Provide a short and direct response. 0.2. What is the difference between the highest and the lowest Employment to population ratio(%) in Small states?
Give a very brief answer. 3.02. What is the difference between the highest and the lowest Employment to population ratio(%) of Angola?
Make the answer very short. 0.6. 